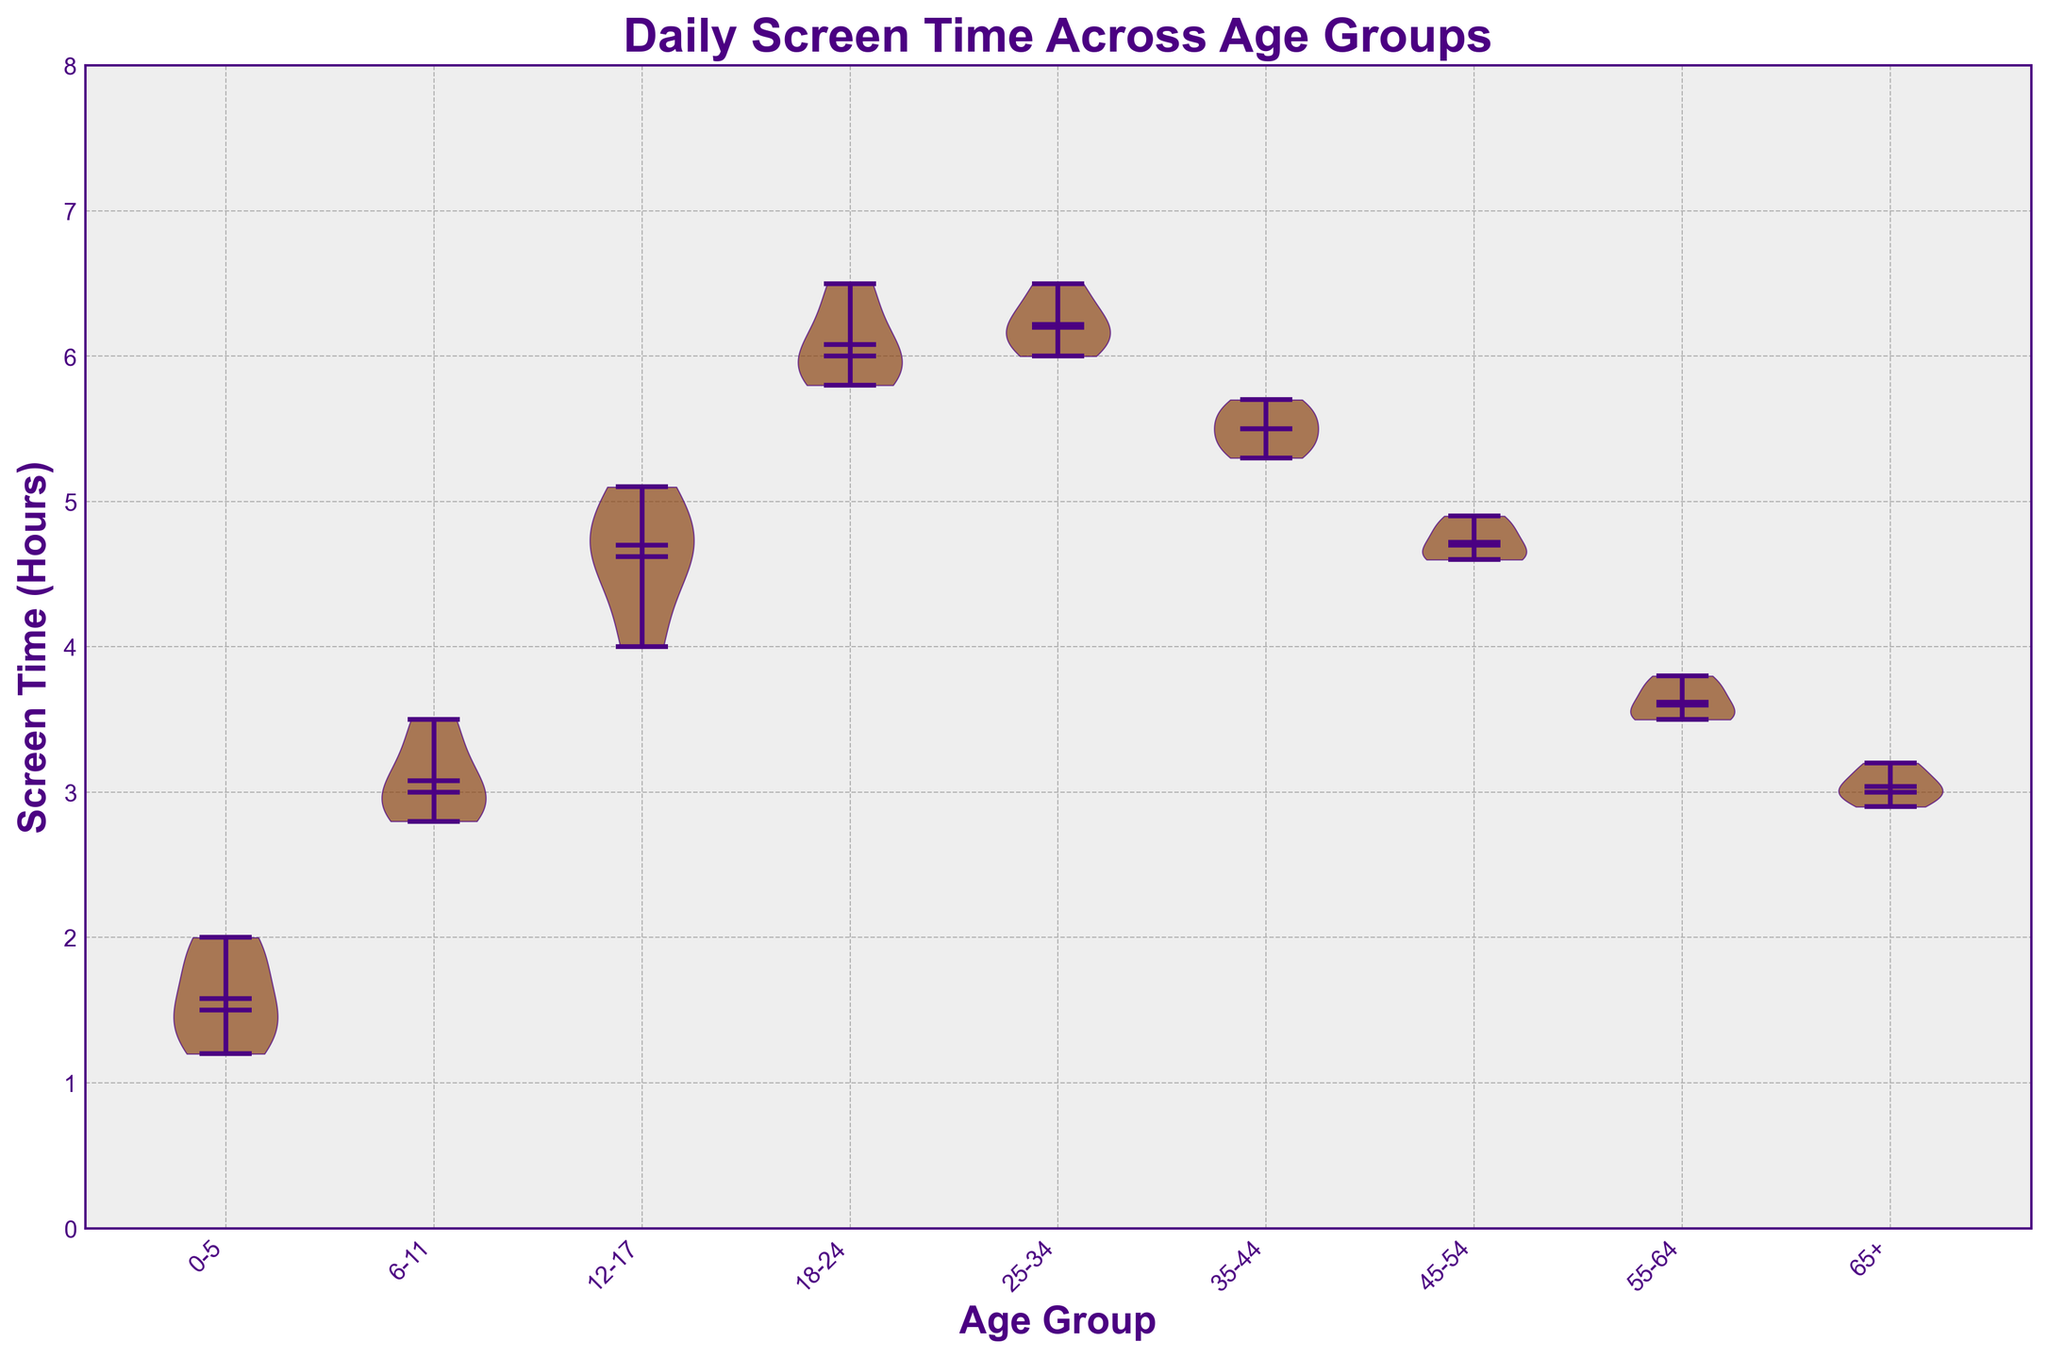What is the title of the chart? The title is displayed at the top center of the chart. It is usually larger and bolder than other text elements.
Answer: Daily Screen Time Across Age Groups How many age groups are represented in the chart? Count the unique ticks along the x-axis, each representing a different age group.
Answer: 9 What color are the violin plots in the chart? Observe the filled color of the violin plots.
Answer: Brown with a hint of purple for the edges Which age group has the highest median screen time? Locate the horizontal line in the middle of each violin plot indicating the median value, then identify which plot has the highest position for this line.
Answer: 18-24 What is the range of screen time for the 12-17 age group? Look at the vertical spread of the 12-17 violin plot, from the lowest point to the highest point of the plot.
Answer: 4.0 to 5.1 hours Which age group shows the least variation in screen time? Identify the violin plot with the smallest width, indicating less dispersion.
Answer: 25-34 Compare the mean screen time of the 6-11 and 18-24 age groups. Which one is higher? Look at the horizontal lines within the violin plots that represent the means of these two age groups. The higher positioned line indicates the higher mean.
Answer: 18-24 How does the screen time of the age group 35-44 compare to that of age group 45-54? Compare the median values (horizontal lines in the middle) of the two groups' violin plots.
Answer: 35-44 is higher What is the approximate screen time for the 0-5 age group? Observe the position and length of the violin plot for 0-5 to estimate the overall range and central tendency.
Answer: Around 1.2 to 2.0 hours Is there an age group with screen time consistently above 5 hours? Look for any violin plot where the bottom edge is still above the 5-hour mark.
Answer: No 